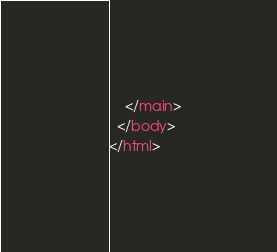Convert code to text. <code><loc_0><loc_0><loc_500><loc_500><_HTML_>    </main>
  </body>
</html>
</code> 